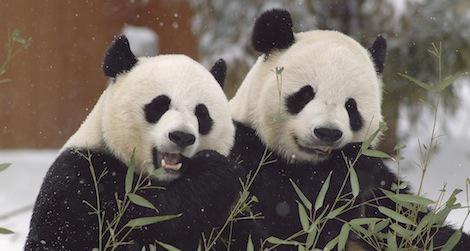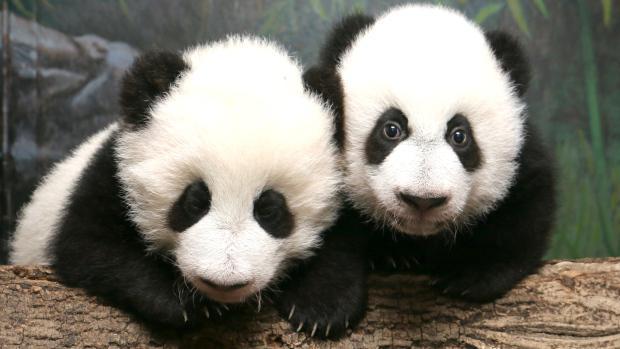The first image is the image on the left, the second image is the image on the right. Considering the images on both sides, is "There are no more than three pandas." valid? Answer yes or no. No. 